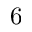<formula> <loc_0><loc_0><loc_500><loc_500>6</formula> 